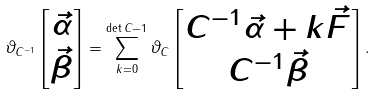<formula> <loc_0><loc_0><loc_500><loc_500>\vartheta _ { C ^ { - 1 } } \left [ \begin{matrix} \vec { \alpha } \\ \vec { \beta } \end{matrix} \right ] = \sum _ { k = 0 } ^ { \det C - 1 } \vartheta _ { C } \left [ \begin{matrix} C ^ { - 1 } \vec { \alpha } + k \vec { F } \\ C ^ { - 1 } \vec { \beta } \end{matrix} \right ] .</formula> 